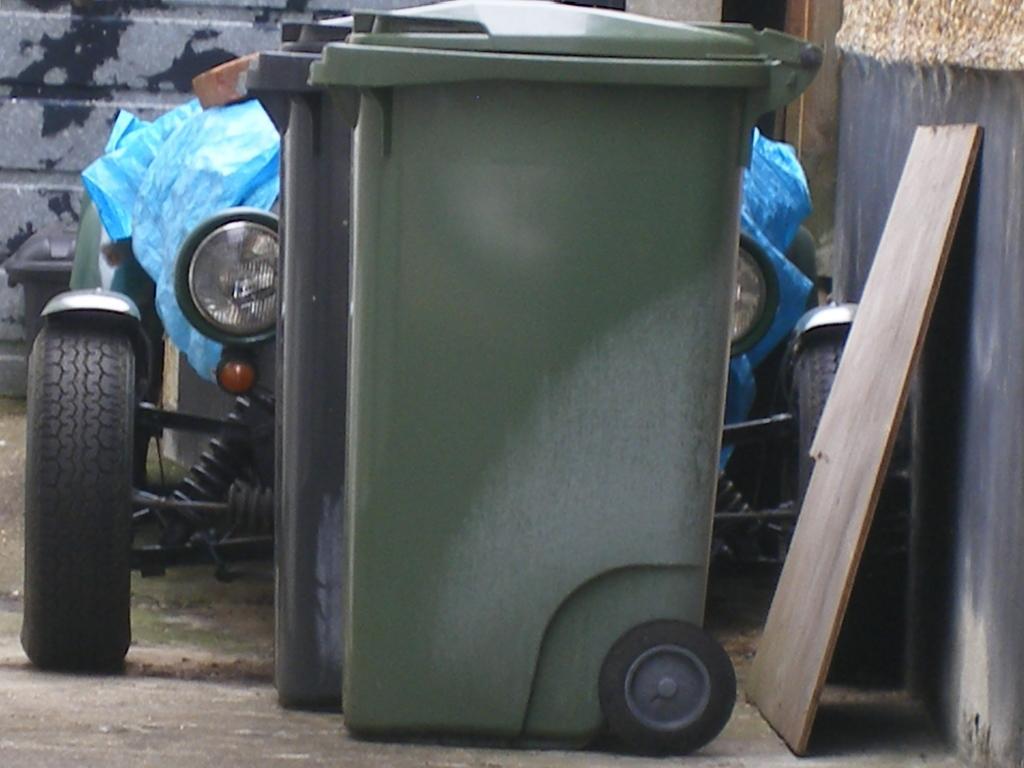Please provide a concise description of this image. There is a dustbin in the middle of this image, and there is a vehicle present behind to this dustbin, and there is a wall in the background. There is a wooden object present on the right side of this image. 